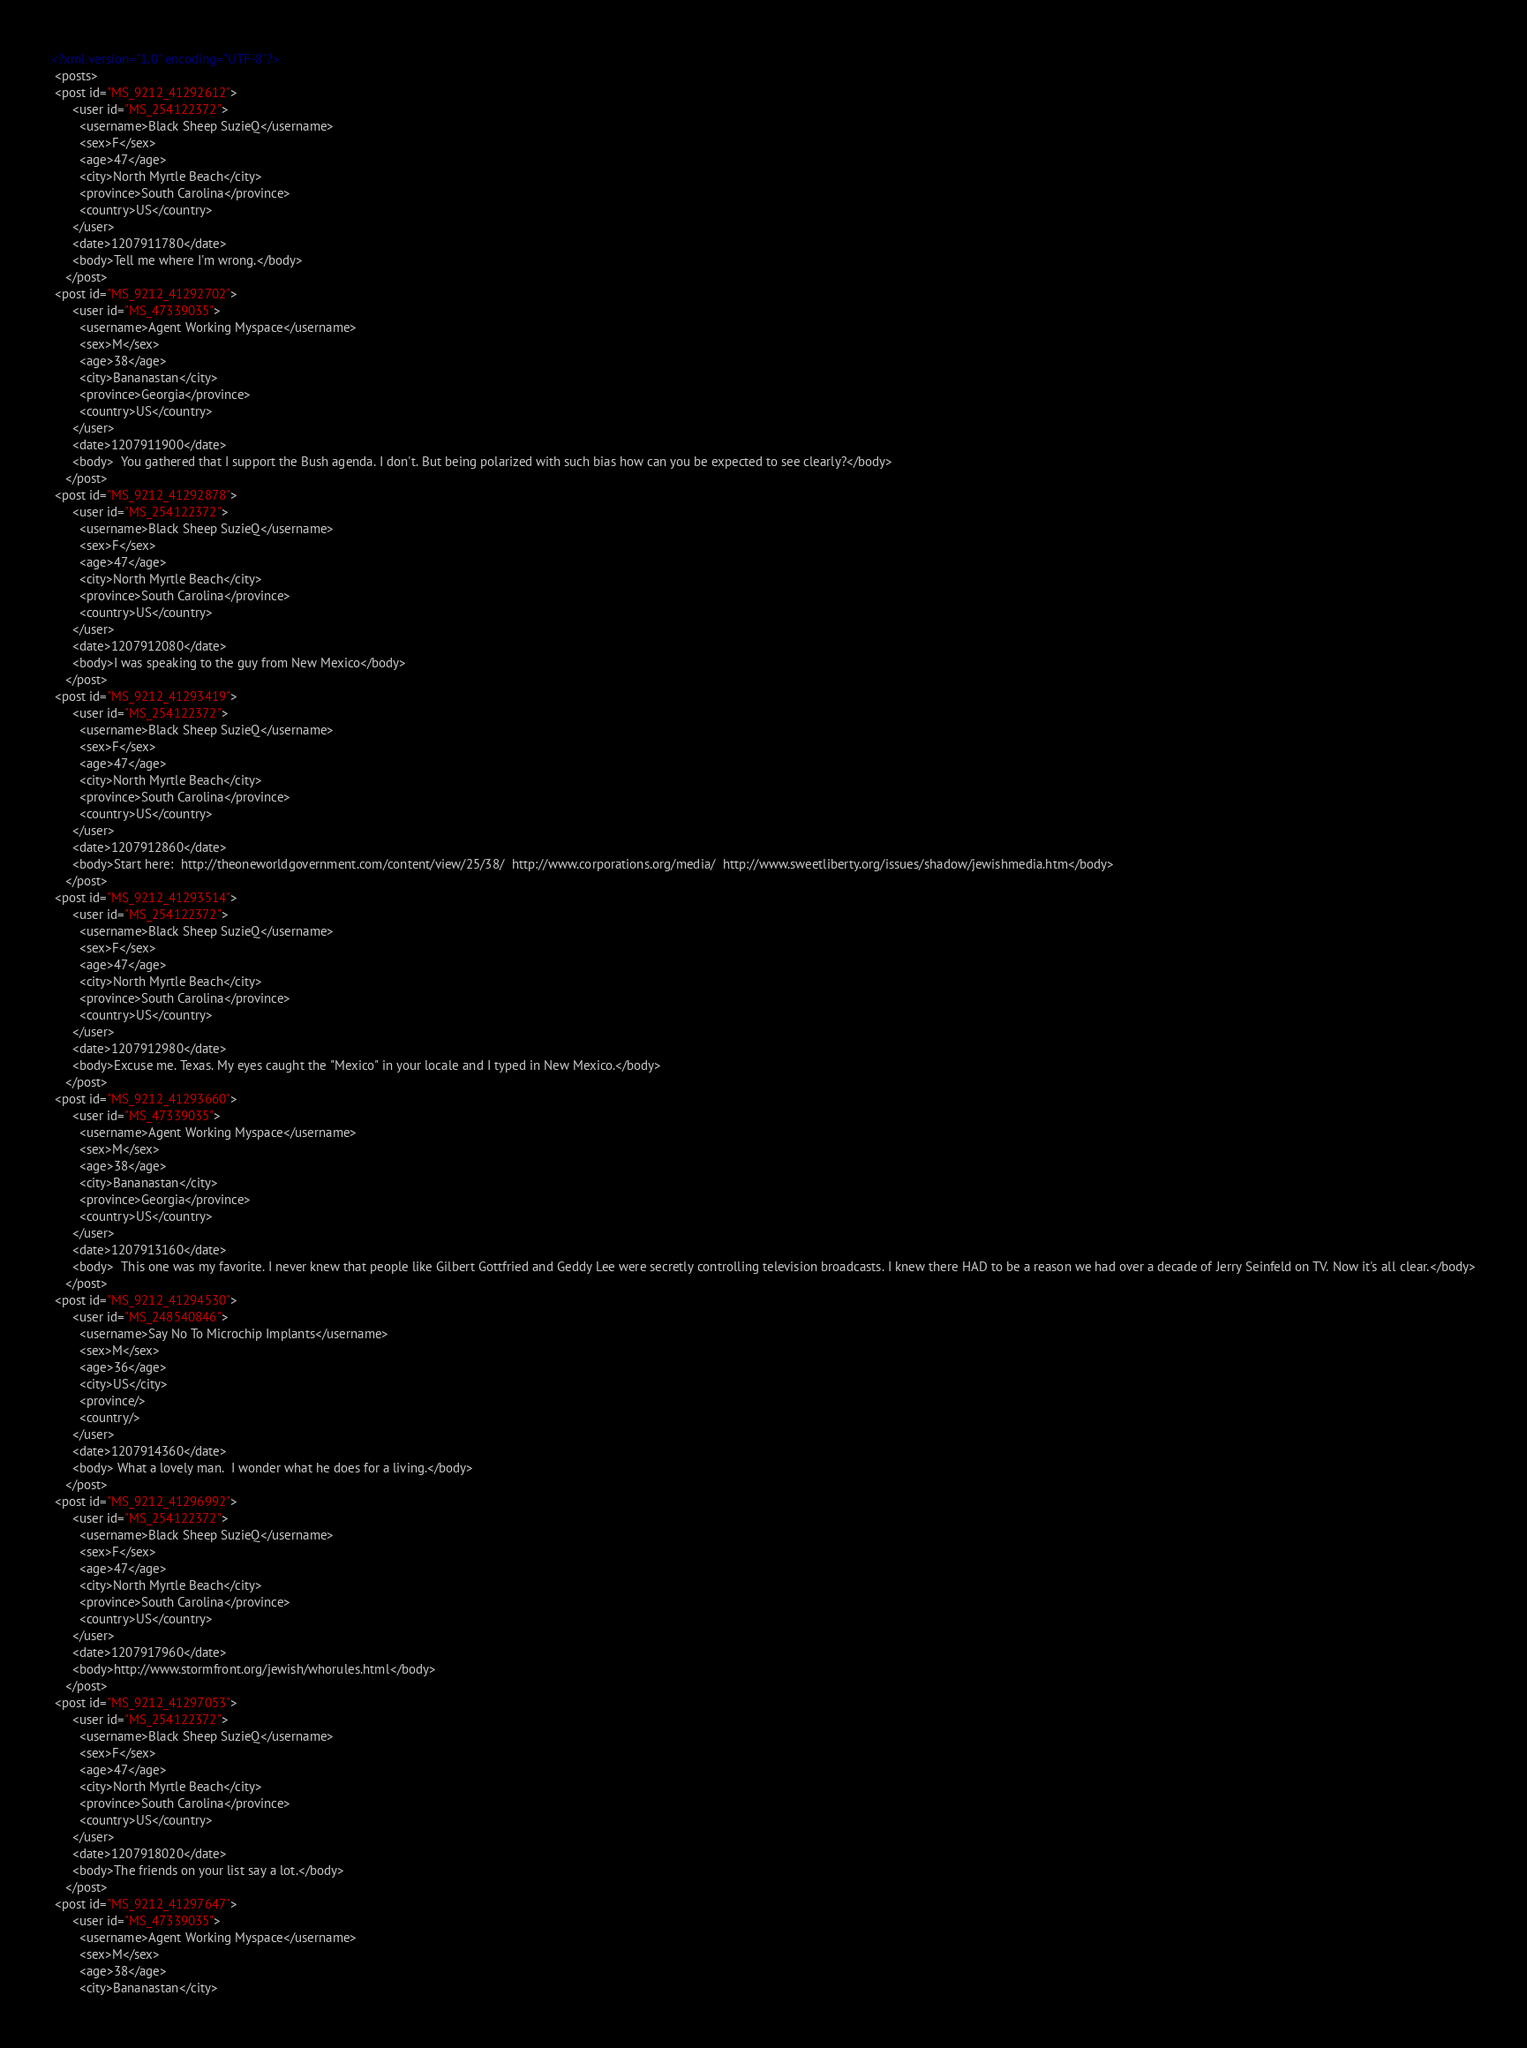Convert code to text. <code><loc_0><loc_0><loc_500><loc_500><_XML_><?xml version="1.0" encoding="UTF-8"?> 
 <posts> 
 <post id="MS_9212_41292612">
      <user id="MS_254122372">
        <username>Black Sheep SuzieQ</username>
        <sex>F</sex>
        <age>47</age>
        <city>North Myrtle Beach</city>
        <province>South Carolina</province>
        <country>US</country>
      </user>
      <date>1207911780</date>
      <body>Tell me where I'm wrong.</body>
    </post> 
 <post id="MS_9212_41292702">
      <user id="MS_47339035">
        <username>Agent Working Myspace</username>
        <sex>M</sex>
        <age>38</age>
        <city>Bananastan</city>
        <province>Georgia</province>
        <country>US</country>
      </user>
      <date>1207911900</date>
      <body>  You gathered that I support the Bush agenda. I don't. But being polarized with such bias how can you be expected to see clearly?</body>
    </post> 
 <post id="MS_9212_41292878">
      <user id="MS_254122372">
        <username>Black Sheep SuzieQ</username>
        <sex>F</sex>
        <age>47</age>
        <city>North Myrtle Beach</city>
        <province>South Carolina</province>
        <country>US</country>
      </user>
      <date>1207912080</date>
      <body>I was speaking to the guy from New Mexico</body>
    </post> 
 <post id="MS_9212_41293419">
      <user id="MS_254122372">
        <username>Black Sheep SuzieQ</username>
        <sex>F</sex>
        <age>47</age>
        <city>North Myrtle Beach</city>
        <province>South Carolina</province>
        <country>US</country>
      </user>
      <date>1207912860</date>
      <body>Start here:  http://theoneworldgovernment.com/content/view/25/38/  http://www.corporations.org/media/  http://www.sweetliberty.org/issues/shadow/jewishmedia.htm</body>
    </post> 
 <post id="MS_9212_41293514">
      <user id="MS_254122372">
        <username>Black Sheep SuzieQ</username>
        <sex>F</sex>
        <age>47</age>
        <city>North Myrtle Beach</city>
        <province>South Carolina</province>
        <country>US</country>
      </user>
      <date>1207912980</date>
      <body>Excuse me. Texas. My eyes caught the "Mexico" in your locale and I typed in New Mexico.</body>
    </post> 
 <post id="MS_9212_41293660">
      <user id="MS_47339035">
        <username>Agent Working Myspace</username>
        <sex>M</sex>
        <age>38</age>
        <city>Bananastan</city>
        <province>Georgia</province>
        <country>US</country>
      </user>
      <date>1207913160</date>
      <body>  This one was my favorite. I never knew that people like Gilbert Gottfried and Geddy Lee were secretly controlling television broadcasts. I knew there HAD to be a reason we had over a decade of Jerry Seinfeld on TV. Now it's all clear.</body>
    </post> 
 <post id="MS_9212_41294530">
      <user id="MS_248540846">
        <username>Say No To Microchip Implants</username>
        <sex>M</sex>
        <age>36</age>
        <city>US</city>
        <province/>
        <country/>
      </user>
      <date>1207914360</date>
      <body> What a lovely man.  I wonder what he does for a living.</body>
    </post> 
 <post id="MS_9212_41296992">
      <user id="MS_254122372">
        <username>Black Sheep SuzieQ</username>
        <sex>F</sex>
        <age>47</age>
        <city>North Myrtle Beach</city>
        <province>South Carolina</province>
        <country>US</country>
      </user>
      <date>1207917960</date>
      <body>http://www.stormfront.org/jewish/whorules.html</body>
    </post> 
 <post id="MS_9212_41297053">
      <user id="MS_254122372">
        <username>Black Sheep SuzieQ</username>
        <sex>F</sex>
        <age>47</age>
        <city>North Myrtle Beach</city>
        <province>South Carolina</province>
        <country>US</country>
      </user>
      <date>1207918020</date>
      <body>The friends on your list say a lot.</body>
    </post> 
 <post id="MS_9212_41297647">
      <user id="MS_47339035">
        <username>Agent Working Myspace</username>
        <sex>M</sex>
        <age>38</age>
        <city>Bananastan</city></code> 